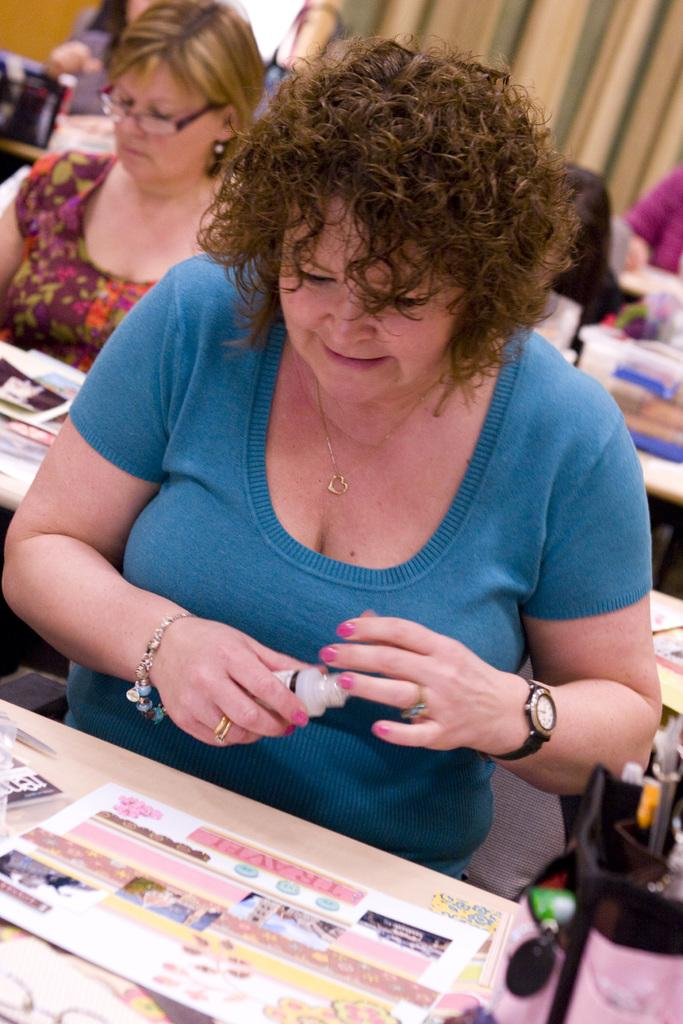What is the woman in the image holding? The woman is holding an object in the image. Can you describe what is at the bottom of the image? There are things and objects at the bottom of the image. What can be seen in the background of the image? There are people and things visible in the background of the image. What type of wealth is visible in the image? There is no indication of wealth in the image; it does not contain any objects or symbols associated with wealth. 